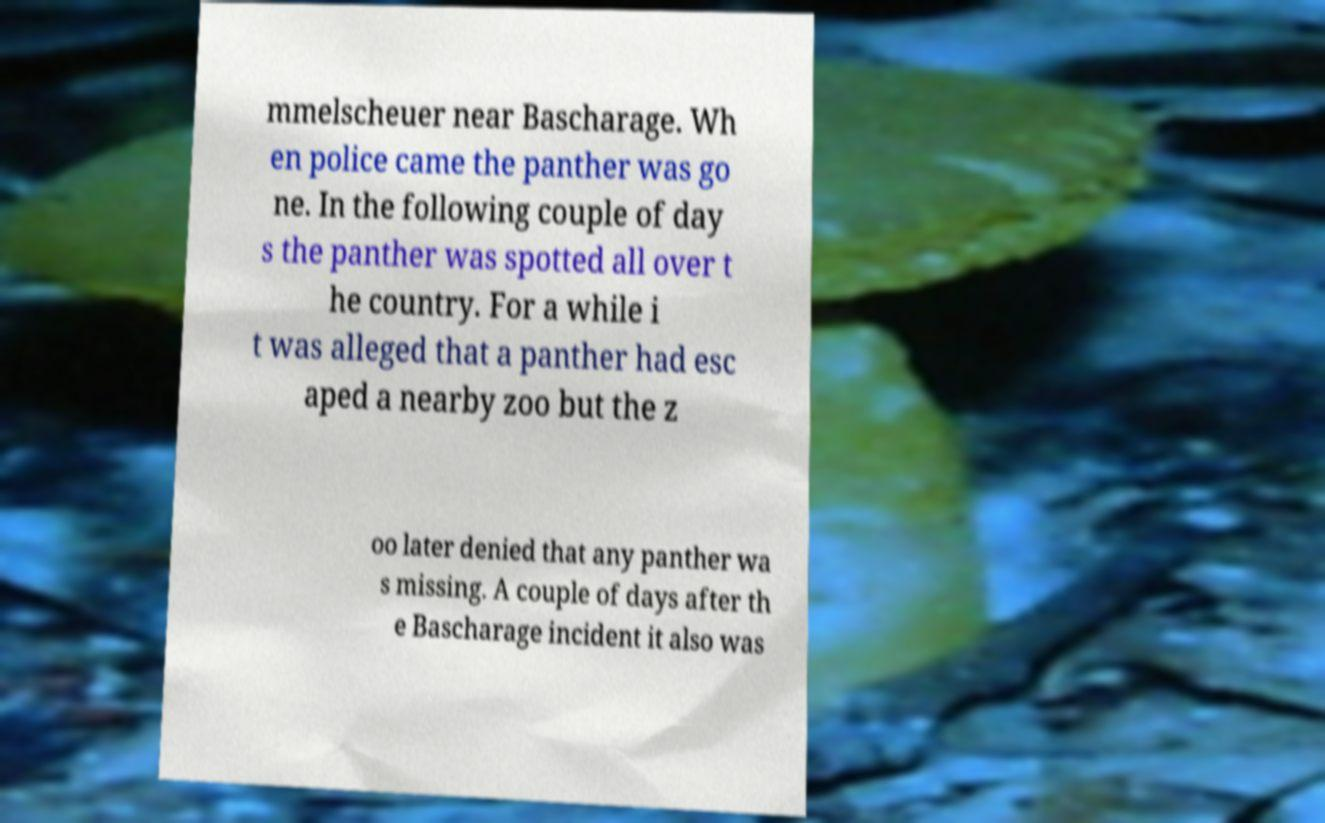I need the written content from this picture converted into text. Can you do that? mmelscheuer near Bascharage. Wh en police came the panther was go ne. In the following couple of day s the panther was spotted all over t he country. For a while i t was alleged that a panther had esc aped a nearby zoo but the z oo later denied that any panther wa s missing. A couple of days after th e Bascharage incident it also was 